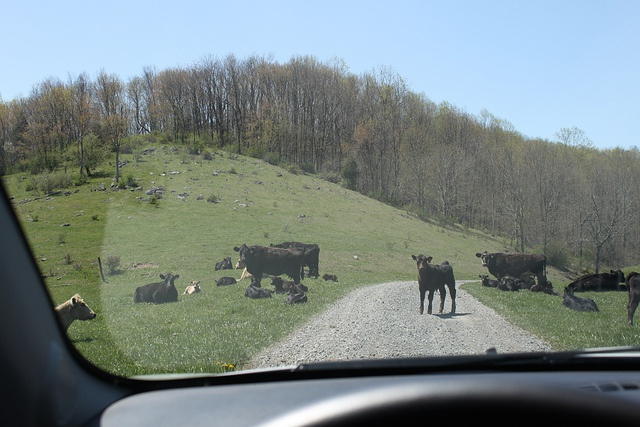Describe the objects in this image and their specific colors. I can see car in lightblue, black, darkgray, and gray tones, cow in lightblue, gray, and darkgray tones, cow in lightblue, black, gray, and purple tones, cow in lightblue, black, gray, and darkgray tones, and cow in lightblue, black, gray, and purple tones in this image. 